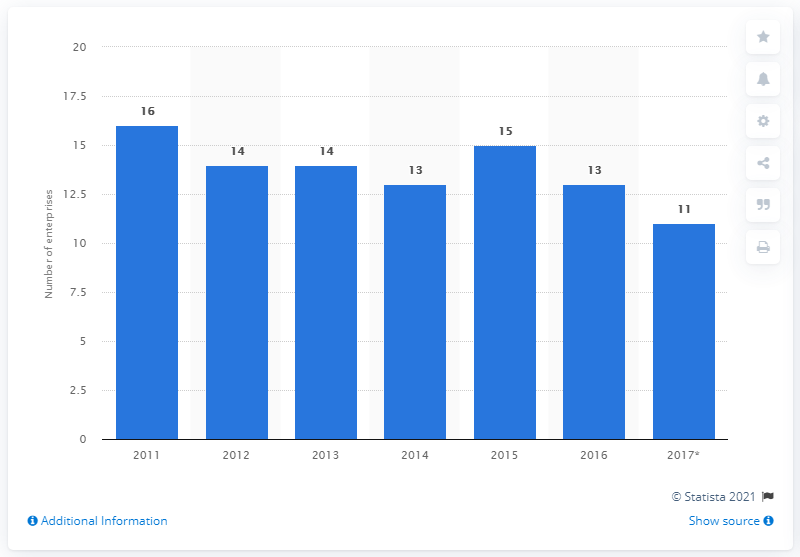Highlight a few significant elements in this photo. There are 15 enterprises in North Macedonia that manufacture tobacco products. 